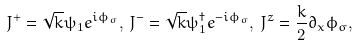<formula> <loc_0><loc_0><loc_500><loc_500>J ^ { + } = \sqrt { k } \psi _ { 1 } e ^ { i \phi _ { \sigma } } , \, J ^ { - } = \sqrt { k } \psi _ { 1 } ^ { \dagger } e ^ { - i \phi _ { \sigma } } , \, J ^ { z } = \frac { k } { 2 } \partial _ { x } \phi _ { \sigma } ,</formula> 